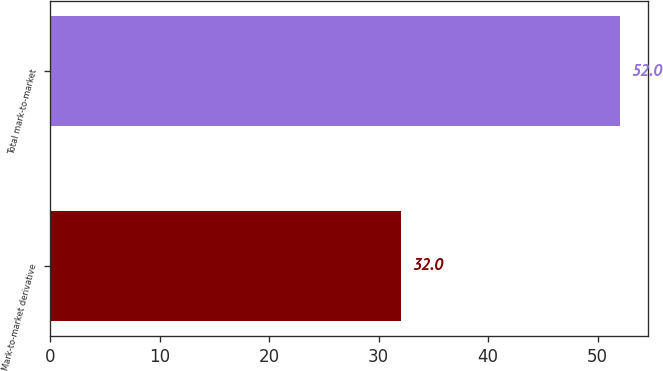<chart> <loc_0><loc_0><loc_500><loc_500><bar_chart><fcel>Mark-to-market derivative<fcel>Total mark-to-market<nl><fcel>32<fcel>52<nl></chart> 